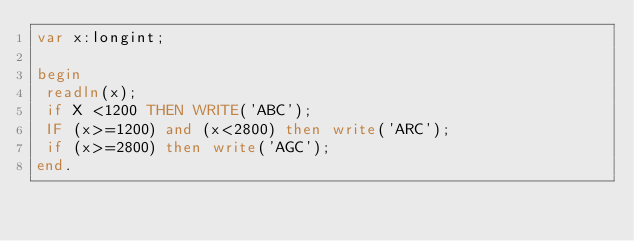Convert code to text. <code><loc_0><loc_0><loc_500><loc_500><_Pascal_>var x:longint;

begin
 readln(x);
 if X <1200 THEN WRITE('ABC');
 IF (x>=1200) and (x<2800) then write('ARC');
 if (x>=2800) then write('AGC');
end.</code> 